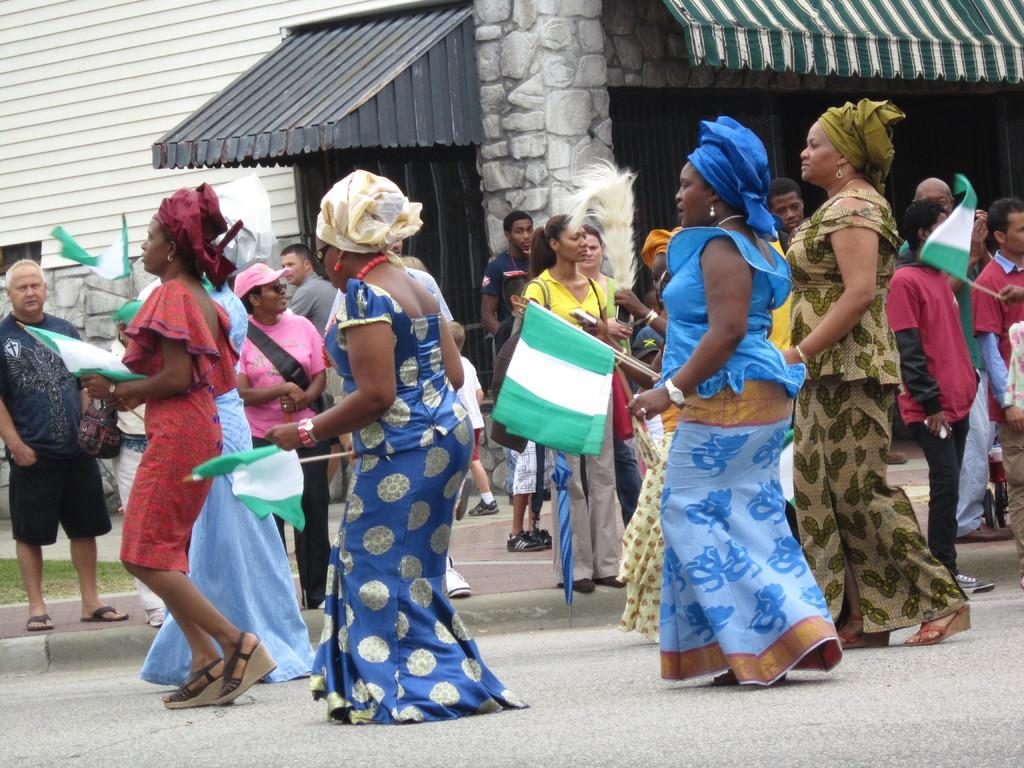What is happening in the image involving a group of people? There is a group of women in the image, and they are walking on the street. What are the women holding in the image? The women are holding green and white flags. What can be seen in the background of the image? There is a house in the background of the image. What is the color of the canopy shed on the house? The canopy shed on the house has a green color. What is the main entrance of the house called? The house has a door as its main entrance. What type of mint is growing on the street in the image? There is no mint visible in the image; the women are walking on the street holding flags. 